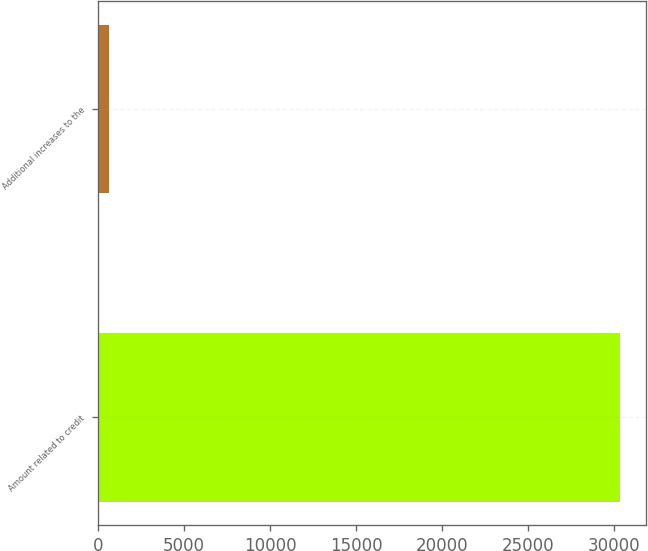Convert chart to OTSL. <chart><loc_0><loc_0><loc_500><loc_500><bar_chart><fcel>Amount related to credit<fcel>Additional increases to the<nl><fcel>30339.1<fcel>636<nl></chart> 